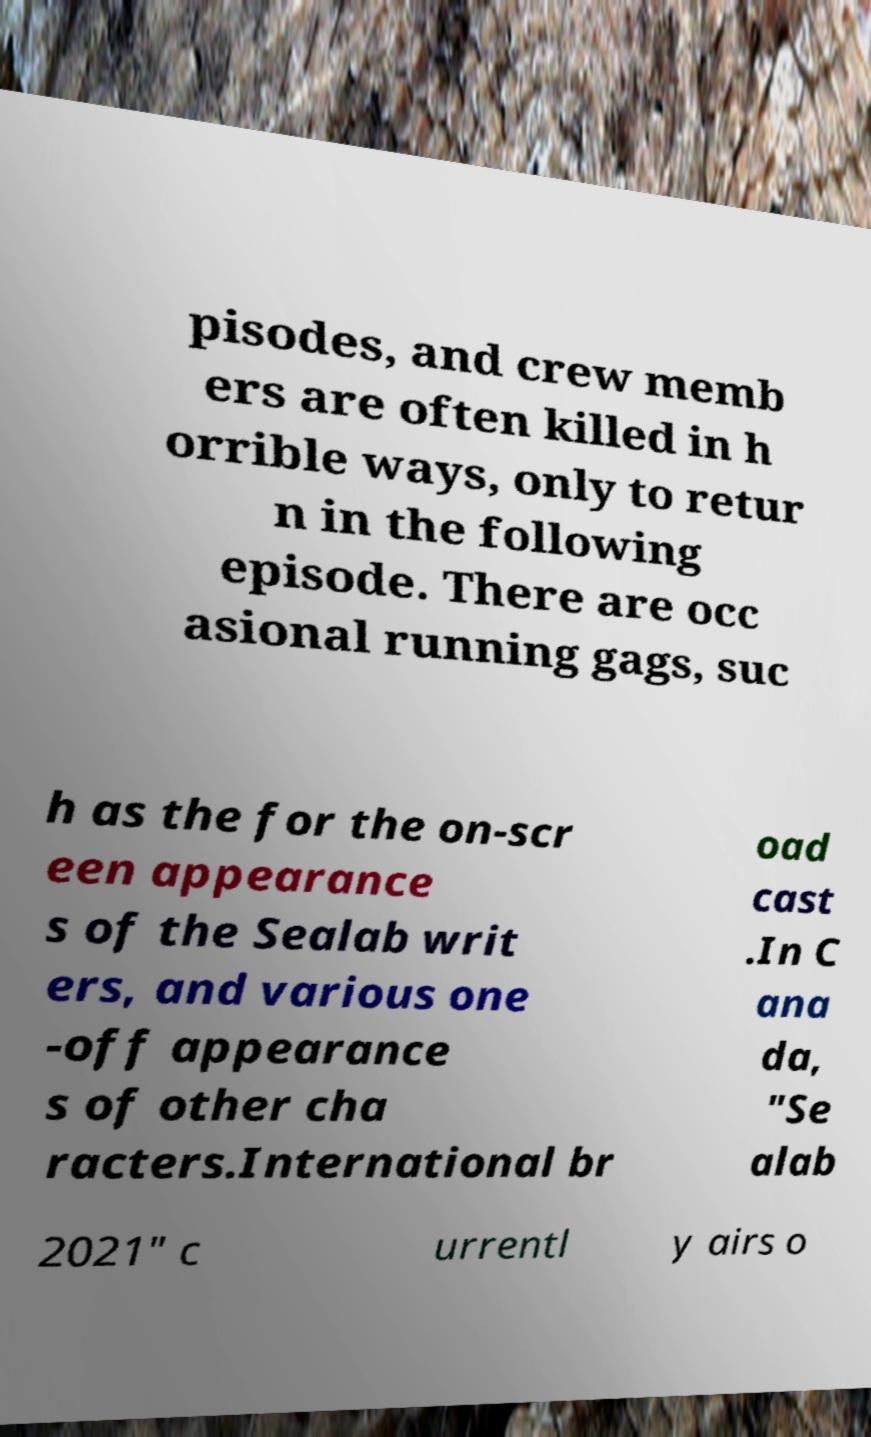I need the written content from this picture converted into text. Can you do that? pisodes, and crew memb ers are often killed in h orrible ways, only to retur n in the following episode. There are occ asional running gags, suc h as the for the on-scr een appearance s of the Sealab writ ers, and various one -off appearance s of other cha racters.International br oad cast .In C ana da, "Se alab 2021" c urrentl y airs o 